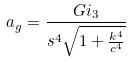<formula> <loc_0><loc_0><loc_500><loc_500>a _ { g } = \frac { G i _ { 3 } } { s ^ { 4 } \sqrt { 1 + \frac { k ^ { 4 } } { c ^ { 4 } } } }</formula> 